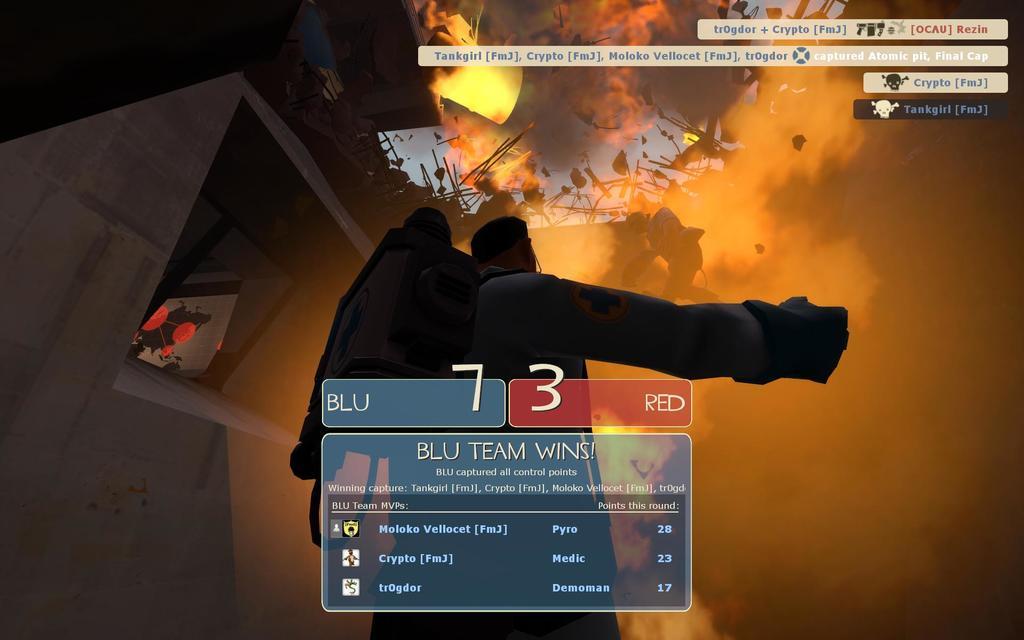Which team won here?
Your answer should be very brief. Blu. 